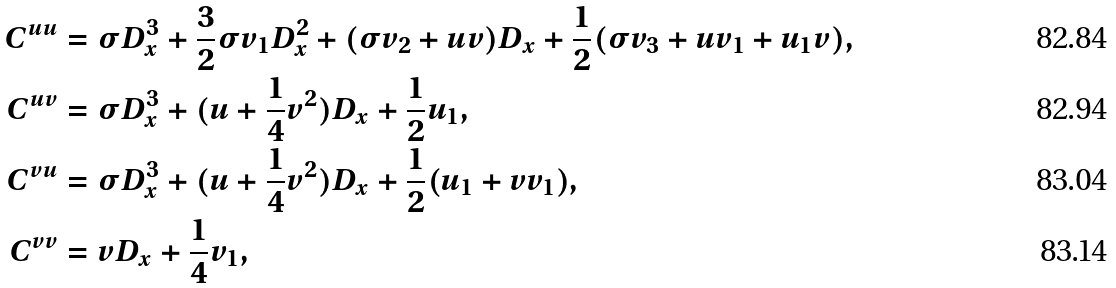Convert formula to latex. <formula><loc_0><loc_0><loc_500><loc_500>C ^ { u u } & = \sigma D _ { x } ^ { 3 } + \frac { 3 } { 2 } \sigma v _ { 1 } D _ { x } ^ { 2 } + ( \sigma v _ { 2 } + u v ) D _ { x } + \frac { 1 } { 2 } ( \sigma v _ { 3 } + u v _ { 1 } + u _ { 1 } v ) , \\ C ^ { u v } & = \sigma D _ { x } ^ { 3 } + ( u + \frac { 1 } { 4 } v ^ { 2 } ) D _ { x } + \frac { 1 } { 2 } u _ { 1 } , \\ C ^ { v u } & = \sigma D _ { x } ^ { 3 } + ( u + \frac { 1 } { 4 } v ^ { 2 } ) D _ { x } + \frac { 1 } { 2 } ( u _ { 1 } + v v _ { 1 } ) , \\ C ^ { v v } & = v D _ { x } + \frac { 1 } { 4 } v _ { 1 } ,</formula> 